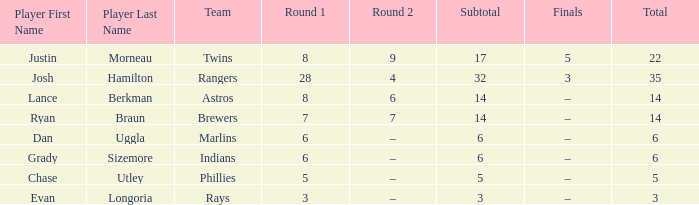Which player has a subtotal of more than 3 and more than 8 in round 1? Josh Hamilton. 